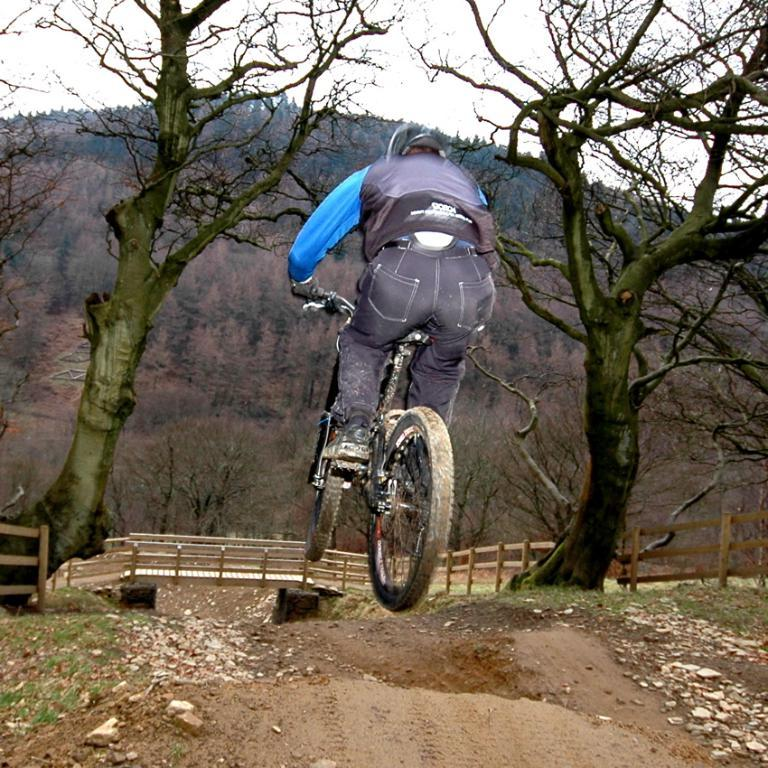What is the main subject of the image? There is a person riding a bicycle in the image. How is the person riding the bicycle? The person appears to be riding in the air. What can be seen in the background of the image? There is a bridge, dried trees, and green trees in the background of the image. What is the color of the sky in the image? The sky is white in color. What type of cable can be seen connecting the person to the bicycle in the image? There is no cable connecting the person to the bicycle in the image; the person is simply riding in the air. What direction is the current flowing in the image? There is no reference to a current or any flowing water in the image. 